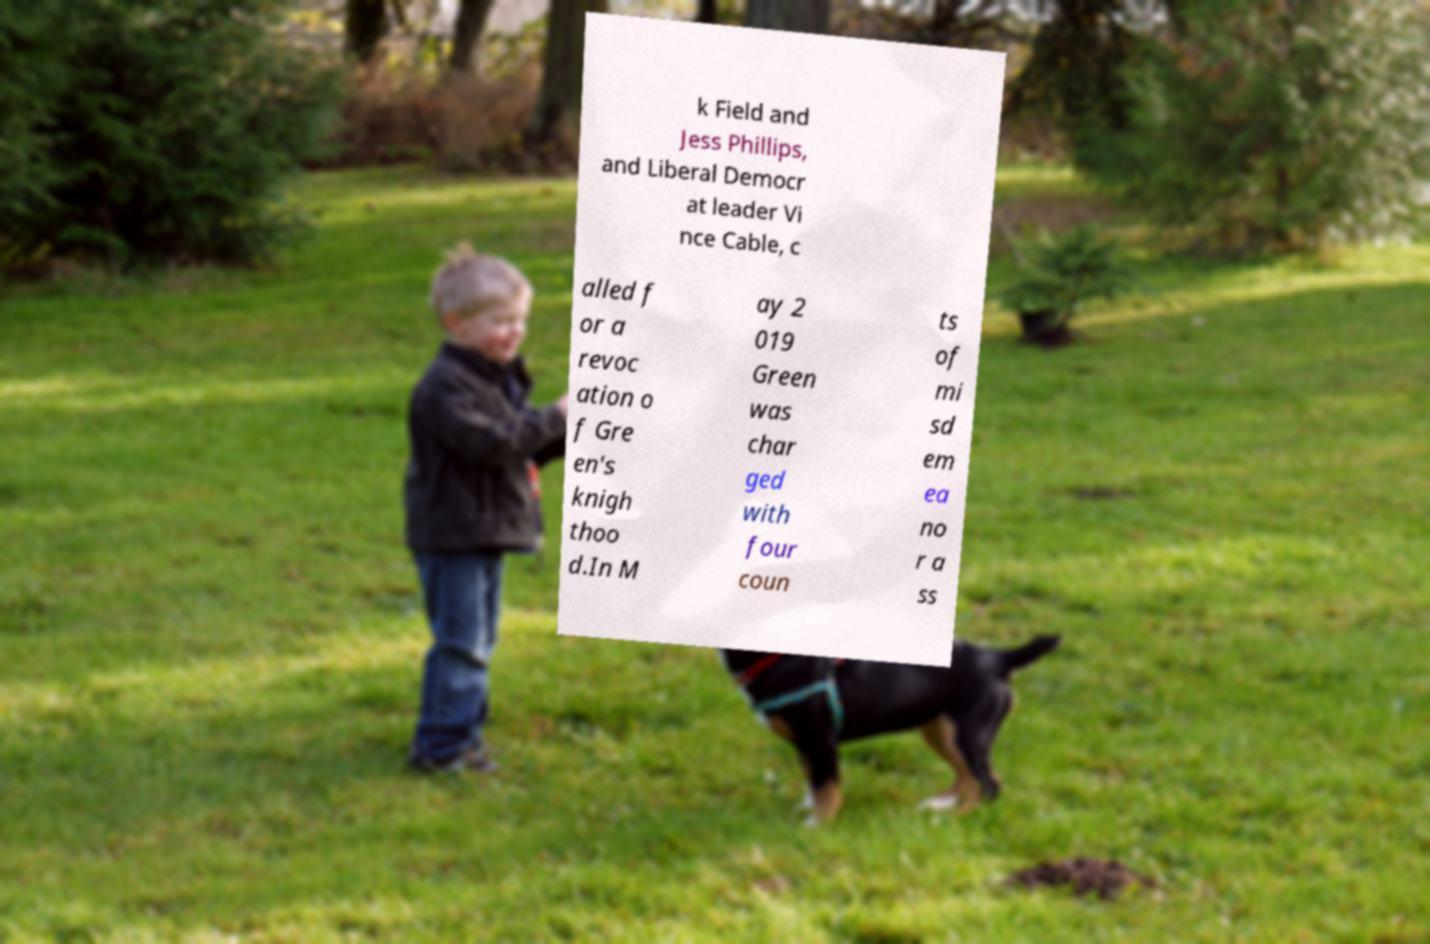Can you accurately transcribe the text from the provided image for me? k Field and Jess Phillips, and Liberal Democr at leader Vi nce Cable, c alled f or a revoc ation o f Gre en's knigh thoo d.In M ay 2 019 Green was char ged with four coun ts of mi sd em ea no r a ss 